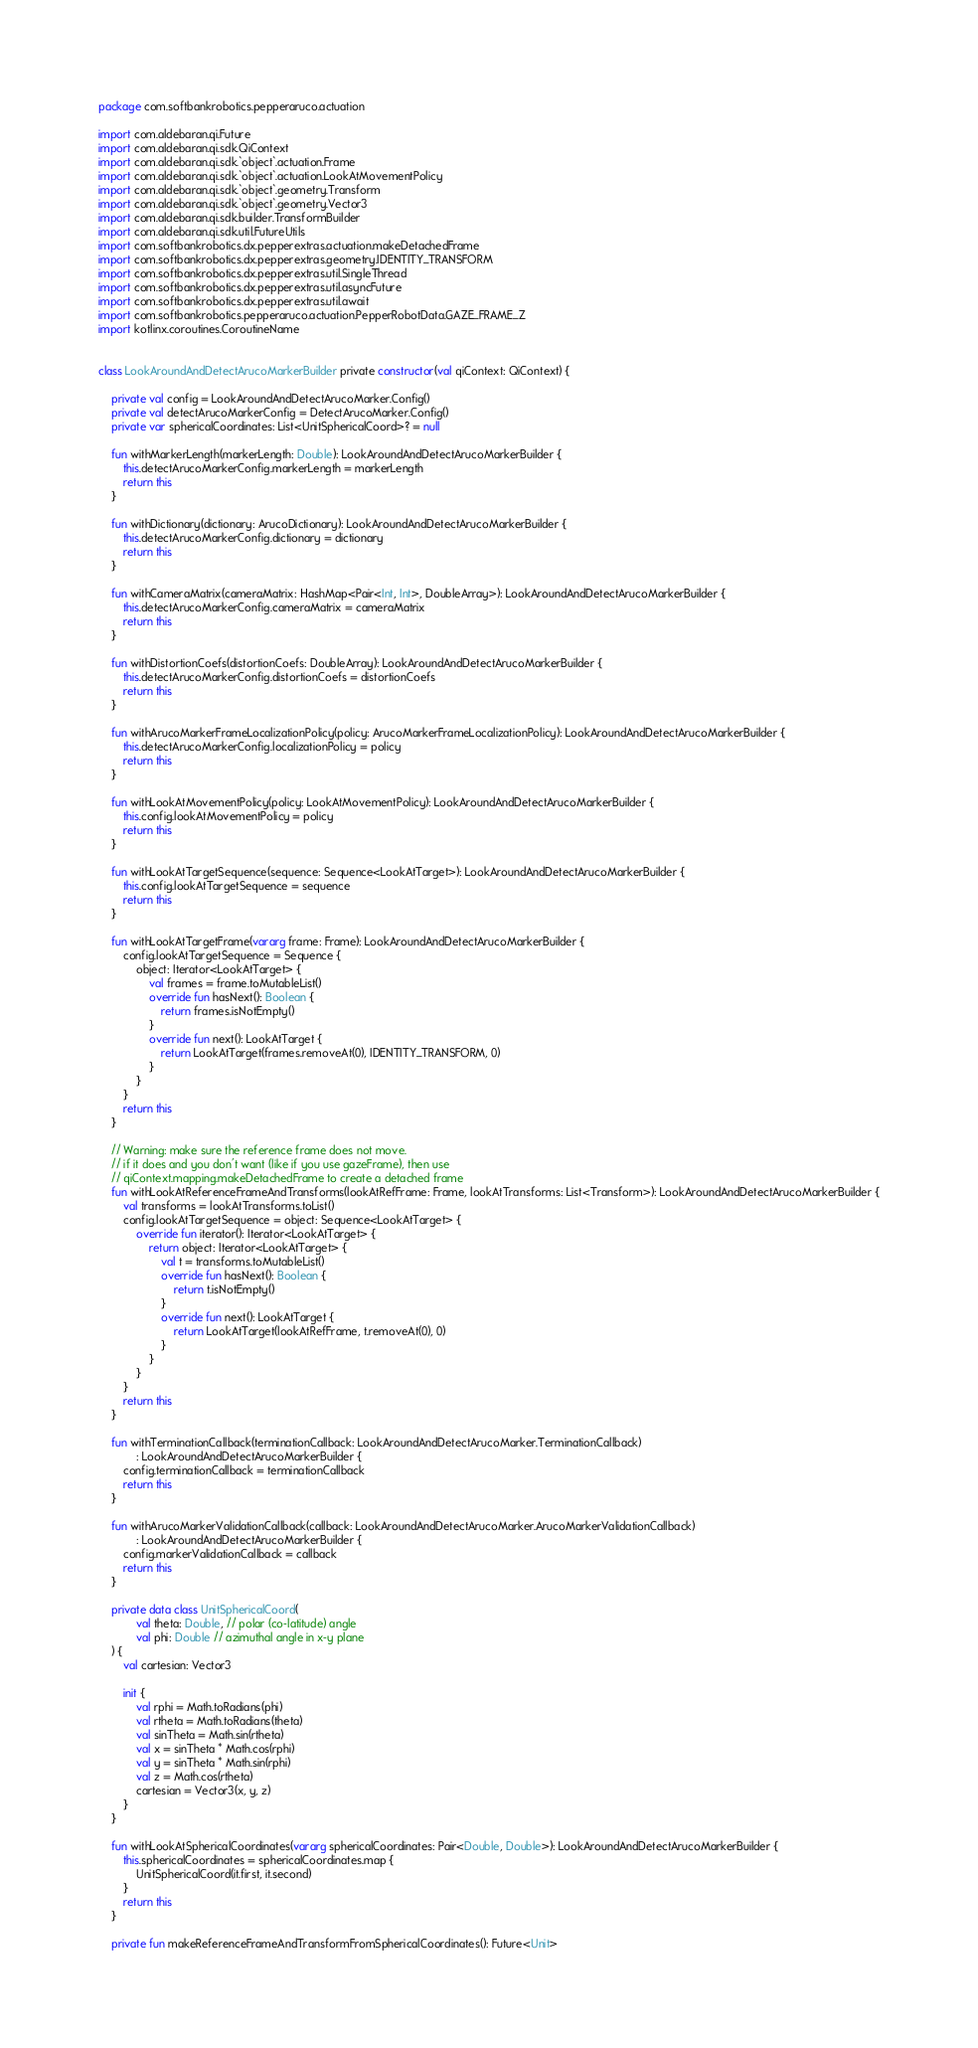Convert code to text. <code><loc_0><loc_0><loc_500><loc_500><_Kotlin_>package com.softbankrobotics.pepperaruco.actuation

import com.aldebaran.qi.Future
import com.aldebaran.qi.sdk.QiContext
import com.aldebaran.qi.sdk.`object`.actuation.Frame
import com.aldebaran.qi.sdk.`object`.actuation.LookAtMovementPolicy
import com.aldebaran.qi.sdk.`object`.geometry.Transform
import com.aldebaran.qi.sdk.`object`.geometry.Vector3
import com.aldebaran.qi.sdk.builder.TransformBuilder
import com.aldebaran.qi.sdk.util.FutureUtils
import com.softbankrobotics.dx.pepperextras.actuation.makeDetachedFrame
import com.softbankrobotics.dx.pepperextras.geometry.IDENTITY_TRANSFORM
import com.softbankrobotics.dx.pepperextras.util.SingleThread
import com.softbankrobotics.dx.pepperextras.util.asyncFuture
import com.softbankrobotics.dx.pepperextras.util.await
import com.softbankrobotics.pepperaruco.actuation.PepperRobotData.GAZE_FRAME_Z
import kotlinx.coroutines.CoroutineName


class LookAroundAndDetectArucoMarkerBuilder private constructor(val qiContext: QiContext) {

    private val config = LookAroundAndDetectArucoMarker.Config()
    private val detectArucoMarkerConfig = DetectArucoMarker.Config()
    private var sphericalCoordinates: List<UnitSphericalCoord>? = null

    fun withMarkerLength(markerLength: Double): LookAroundAndDetectArucoMarkerBuilder {
        this.detectArucoMarkerConfig.markerLength = markerLength
        return this
    }

    fun withDictionary(dictionary: ArucoDictionary): LookAroundAndDetectArucoMarkerBuilder {
        this.detectArucoMarkerConfig.dictionary = dictionary
        return this
    }

    fun withCameraMatrix(cameraMatrix: HashMap<Pair<Int, Int>, DoubleArray>): LookAroundAndDetectArucoMarkerBuilder {
        this.detectArucoMarkerConfig.cameraMatrix = cameraMatrix
        return this
    }

    fun withDistortionCoefs(distortionCoefs: DoubleArray): LookAroundAndDetectArucoMarkerBuilder {
        this.detectArucoMarkerConfig.distortionCoefs = distortionCoefs
        return this
    }

    fun withArucoMarkerFrameLocalizationPolicy(policy: ArucoMarkerFrameLocalizationPolicy): LookAroundAndDetectArucoMarkerBuilder {
        this.detectArucoMarkerConfig.localizationPolicy = policy
        return this
    }

    fun withLookAtMovementPolicy(policy: LookAtMovementPolicy): LookAroundAndDetectArucoMarkerBuilder {
        this.config.lookAtMovementPolicy = policy
        return this
    }

    fun withLookAtTargetSequence(sequence: Sequence<LookAtTarget>): LookAroundAndDetectArucoMarkerBuilder {
        this.config.lookAtTargetSequence = sequence
        return this
    }

    fun withLookAtTargetFrame(vararg frame: Frame): LookAroundAndDetectArucoMarkerBuilder {
        config.lookAtTargetSequence = Sequence {
            object: Iterator<LookAtTarget> {
                val frames = frame.toMutableList()
                override fun hasNext(): Boolean {
                    return frames.isNotEmpty()
                }
                override fun next(): LookAtTarget {
                    return LookAtTarget(frames.removeAt(0), IDENTITY_TRANSFORM, 0)
                }
            }
        }
        return this
    }

    // Warning: make sure the reference frame does not move.
    // if it does and you don't want (like if you use gazeFrame), then use
    // qiContext.mapping.makeDetachedFrame to create a detached frame
    fun withLookAtReferenceFrameAndTransforms(lookAtRefFrame: Frame, lookAtTransforms: List<Transform>): LookAroundAndDetectArucoMarkerBuilder {
        val transforms = lookAtTransforms.toList()
        config.lookAtTargetSequence = object: Sequence<LookAtTarget> {
            override fun iterator(): Iterator<LookAtTarget> {
                return object: Iterator<LookAtTarget> {
                    val t = transforms.toMutableList()
                    override fun hasNext(): Boolean {
                        return t.isNotEmpty()
                    }
                    override fun next(): LookAtTarget {
                        return LookAtTarget(lookAtRefFrame, t.removeAt(0), 0)
                    }
                }
            }
        }
        return this
    }

    fun withTerminationCallback(terminationCallback: LookAroundAndDetectArucoMarker.TerminationCallback)
            : LookAroundAndDetectArucoMarkerBuilder {
        config.terminationCallback = terminationCallback
        return this
    }

    fun withArucoMarkerValidationCallback(callback: LookAroundAndDetectArucoMarker.ArucoMarkerValidationCallback)
            : LookAroundAndDetectArucoMarkerBuilder {
        config.markerValidationCallback = callback
        return this
    }

    private data class UnitSphericalCoord(
            val theta: Double, // polar (co-latitude) angle
            val phi: Double // azimuthal angle in x-y plane
    ) {
        val cartesian: Vector3

        init {
            val rphi = Math.toRadians(phi)
            val rtheta = Math.toRadians(theta)
            val sinTheta = Math.sin(rtheta)
            val x = sinTheta * Math.cos(rphi)
            val y = sinTheta * Math.sin(rphi)
            val z = Math.cos(rtheta)
            cartesian = Vector3(x, y, z)
        }
    }

    fun withLookAtSphericalCoordinates(vararg sphericalCoordinates: Pair<Double, Double>): LookAroundAndDetectArucoMarkerBuilder {
        this.sphericalCoordinates = sphericalCoordinates.map {
            UnitSphericalCoord(it.first, it.second)
        }
        return this
    }

    private fun makeReferenceFrameAndTransformFromSphericalCoordinates(): Future<Unit></code> 